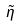<formula> <loc_0><loc_0><loc_500><loc_500>\tilde { \eta }</formula> 